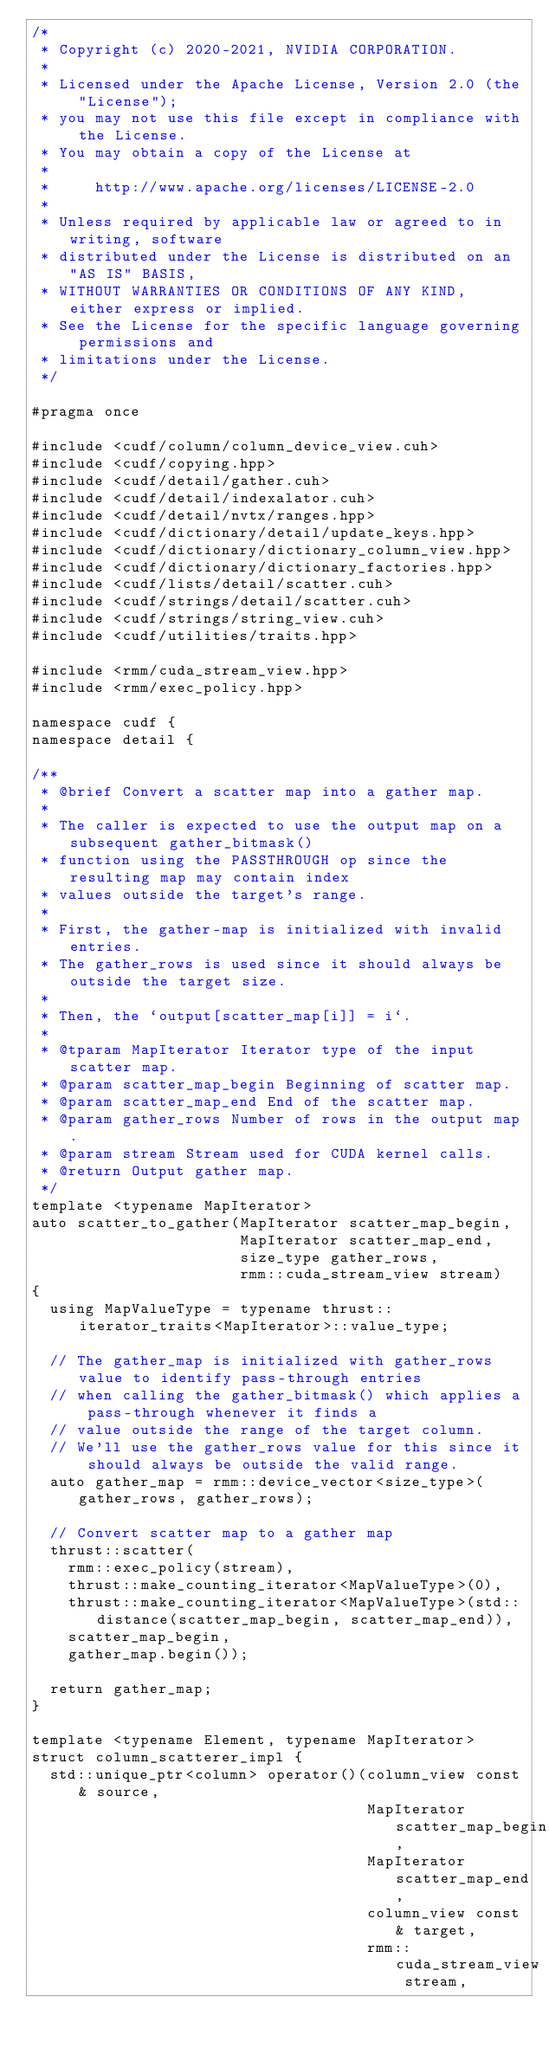<code> <loc_0><loc_0><loc_500><loc_500><_Cuda_>/*
 * Copyright (c) 2020-2021, NVIDIA CORPORATION.
 *
 * Licensed under the Apache License, Version 2.0 (the "License");
 * you may not use this file except in compliance with the License.
 * You may obtain a copy of the License at
 *
 *     http://www.apache.org/licenses/LICENSE-2.0
 *
 * Unless required by applicable law or agreed to in writing, software
 * distributed under the License is distributed on an "AS IS" BASIS,
 * WITHOUT WARRANTIES OR CONDITIONS OF ANY KIND, either express or implied.
 * See the License for the specific language governing permissions and
 * limitations under the License.
 */

#pragma once

#include <cudf/column/column_device_view.cuh>
#include <cudf/copying.hpp>
#include <cudf/detail/gather.cuh>
#include <cudf/detail/indexalator.cuh>
#include <cudf/detail/nvtx/ranges.hpp>
#include <cudf/dictionary/detail/update_keys.hpp>
#include <cudf/dictionary/dictionary_column_view.hpp>
#include <cudf/dictionary/dictionary_factories.hpp>
#include <cudf/lists/detail/scatter.cuh>
#include <cudf/strings/detail/scatter.cuh>
#include <cudf/strings/string_view.cuh>
#include <cudf/utilities/traits.hpp>

#include <rmm/cuda_stream_view.hpp>
#include <rmm/exec_policy.hpp>

namespace cudf {
namespace detail {

/**
 * @brief Convert a scatter map into a gather map.
 *
 * The caller is expected to use the output map on a subsequent gather_bitmask()
 * function using the PASSTHROUGH op since the resulting map may contain index
 * values outside the target's range.
 *
 * First, the gather-map is initialized with invalid entries.
 * The gather_rows is used since it should always be outside the target size.
 *
 * Then, the `output[scatter_map[i]] = i`.
 *
 * @tparam MapIterator Iterator type of the input scatter map.
 * @param scatter_map_begin Beginning of scatter map.
 * @param scatter_map_end End of the scatter map.
 * @param gather_rows Number of rows in the output map.
 * @param stream Stream used for CUDA kernel calls.
 * @return Output gather map.
 */
template <typename MapIterator>
auto scatter_to_gather(MapIterator scatter_map_begin,
                       MapIterator scatter_map_end,
                       size_type gather_rows,
                       rmm::cuda_stream_view stream)
{
  using MapValueType = typename thrust::iterator_traits<MapIterator>::value_type;

  // The gather_map is initialized with gather_rows value to identify pass-through entries
  // when calling the gather_bitmask() which applies a pass-through whenever it finds a
  // value outside the range of the target column.
  // We'll use the gather_rows value for this since it should always be outside the valid range.
  auto gather_map = rmm::device_vector<size_type>(gather_rows, gather_rows);

  // Convert scatter map to a gather map
  thrust::scatter(
    rmm::exec_policy(stream),
    thrust::make_counting_iterator<MapValueType>(0),
    thrust::make_counting_iterator<MapValueType>(std::distance(scatter_map_begin, scatter_map_end)),
    scatter_map_begin,
    gather_map.begin());

  return gather_map;
}

template <typename Element, typename MapIterator>
struct column_scatterer_impl {
  std::unique_ptr<column> operator()(column_view const& source,
                                     MapIterator scatter_map_begin,
                                     MapIterator scatter_map_end,
                                     column_view const& target,
                                     rmm::cuda_stream_view stream,</code> 